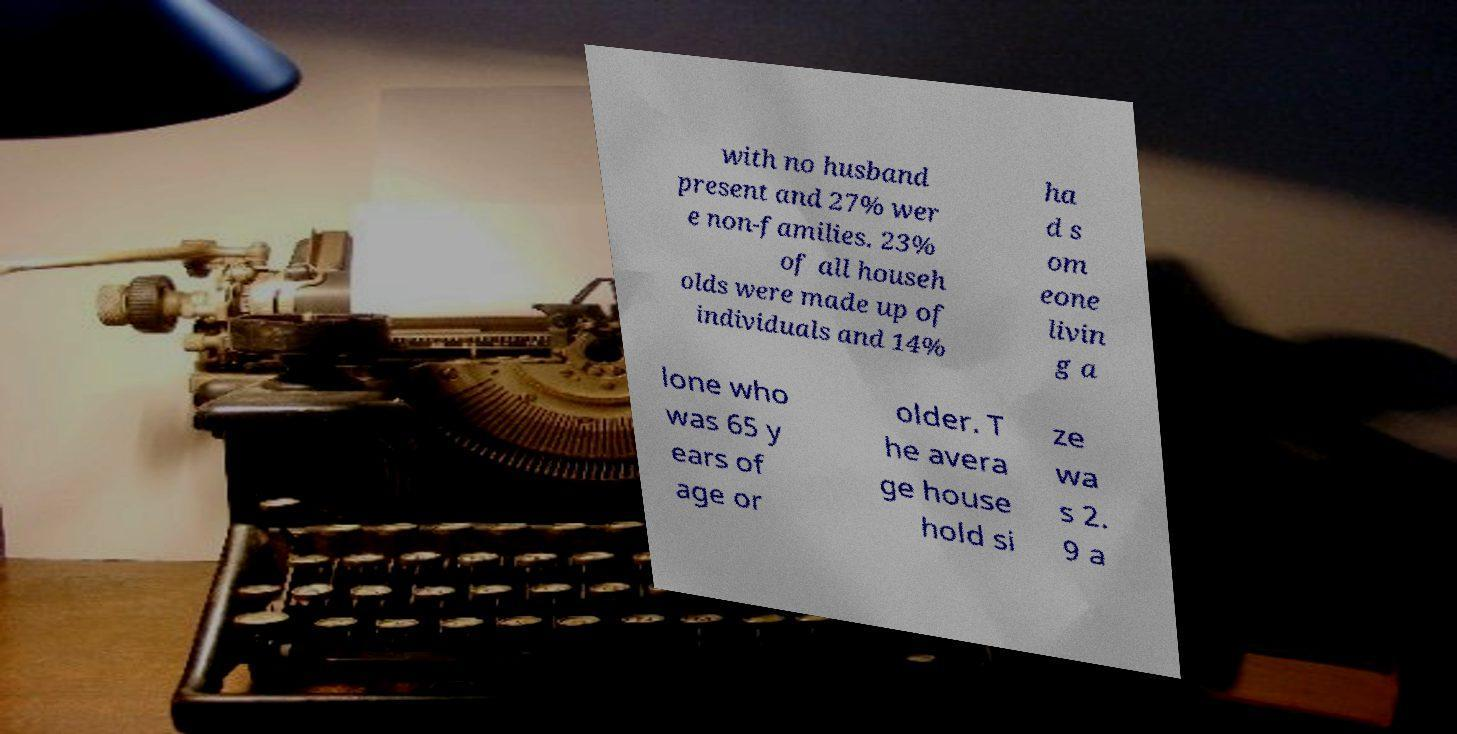For documentation purposes, I need the text within this image transcribed. Could you provide that? with no husband present and 27% wer e non-families. 23% of all househ olds were made up of individuals and 14% ha d s om eone livin g a lone who was 65 y ears of age or older. T he avera ge house hold si ze wa s 2. 9 a 